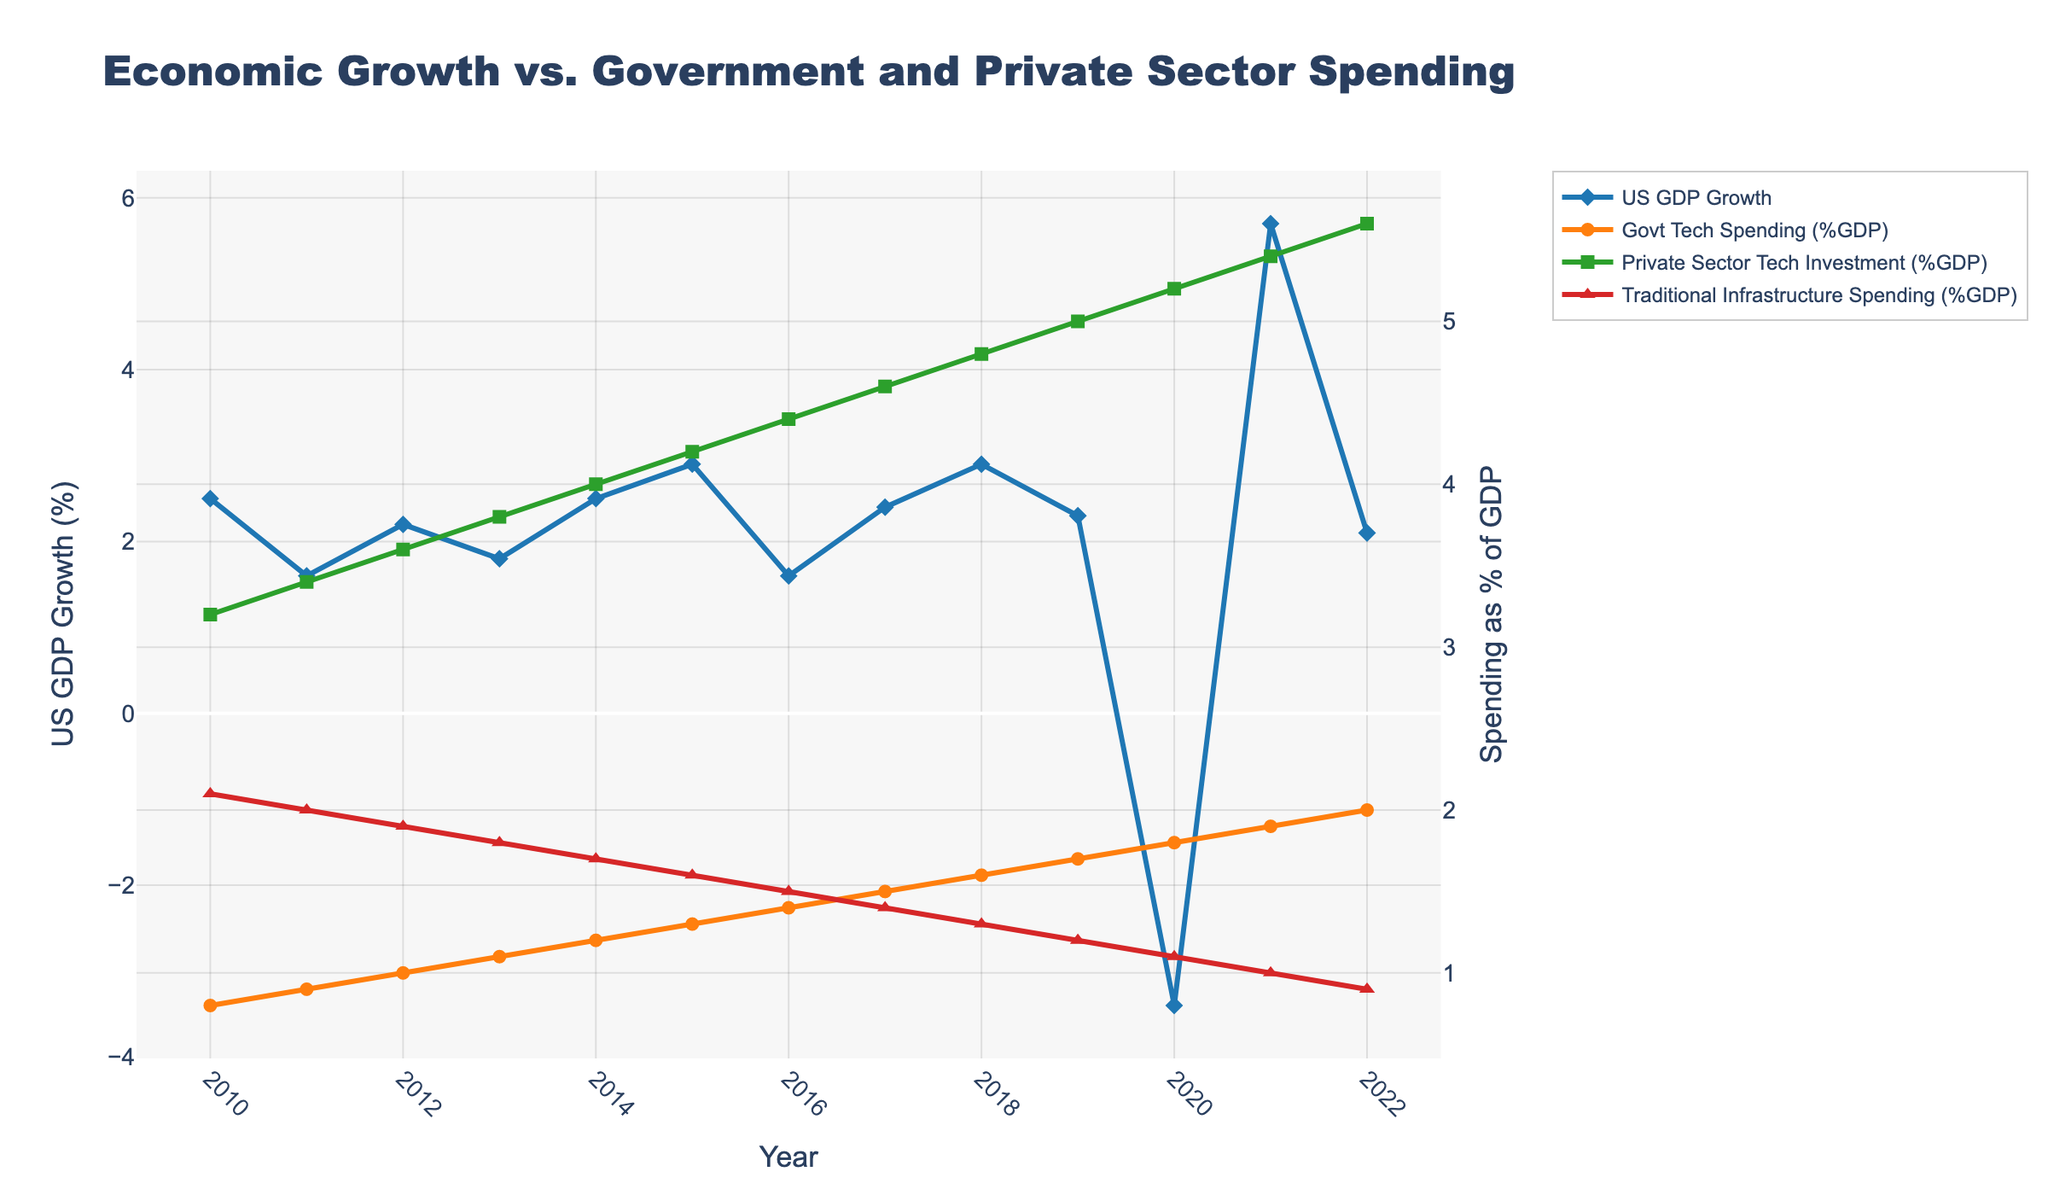what is the percent increase in Govt Tech Spending from 2010 to 2022? Govt Tech Spending as a percentage of GDP in 2010 was 0.8%. In 2022, it was 2.0%. The percent increase is calculated as ((2.0 - 0.8) / 0.8) * 100%.
Answer: 150% What year shows the highest US GDP Growth, and what is the value? By examining the chart, the year with the highest US GDP Growth is 2021, with a value of 5.7%.
Answer: 2021, 5.7% In which year does Traditional Infrastructure Spending %GDP drop below 1%? We observe the trend of Traditional Infrastructure Spending %GDP. It drops below 1% in 2021 and 2022.
Answer: 2021 Which expenditure increased the most from 2010 to 2022, Government Tech Spending or Private Sector Tech Investment? Govt Tech Spending increased from 0.8% to 2.0% (1.2 percentage points), while Private Sector Tech Investment increased from 3.2% to 5.6% (2.4 percentage points). Therefore, Private Sector Tech Investment increased the most.
Answer: Private Sector Tech Investment What is the difference in US GDP Growth between its highest and lowest observed values? The highest US GDP Growth is 5.7% in 2021, while the lowest is -3.4% in 2020. The difference is calculated as 5.7 - (-3.4) = 9.1%.
Answer: 9.1% How many years show a decrease in US GDP Growth as compared to the previous year? By examining the trend lines, the years with a decrease compared to the previous year are 2011, 2013, 2016, 2017, 2019, 2020, and 2022. Counting these gives 7 years.
Answer: 7 years Compare the trend of Govt Tech Spending with Traditional Infrastructure Spending over the years. How are they visually different? Govt Tech Spending has a consistent upward trend, whereas Traditional Infrastructure Spending has a consistent downward trend.
Answer: Upward vs. Downward What is the average US GDP Growth over the 13 years? Sum the values of US GDP Growth and divide by the number of years: (2.5 + 1.6 + 2.2 + 1.8 + 2.5 + 2.9 + 1.6 + 2.4 + 2.9 + 2.3 - 3.4 + 5.7 + 2.1) / 13 = 1.92%.
Answer: 1.92% Between which consecutive years did Govt Tech Spending see the highest increase? By examining the slope of the Govt Tech Spending line, the highest increase occurs between 2010 and 2011, when it increased by 0.1 percentage points.
Answer: 2010-2011 